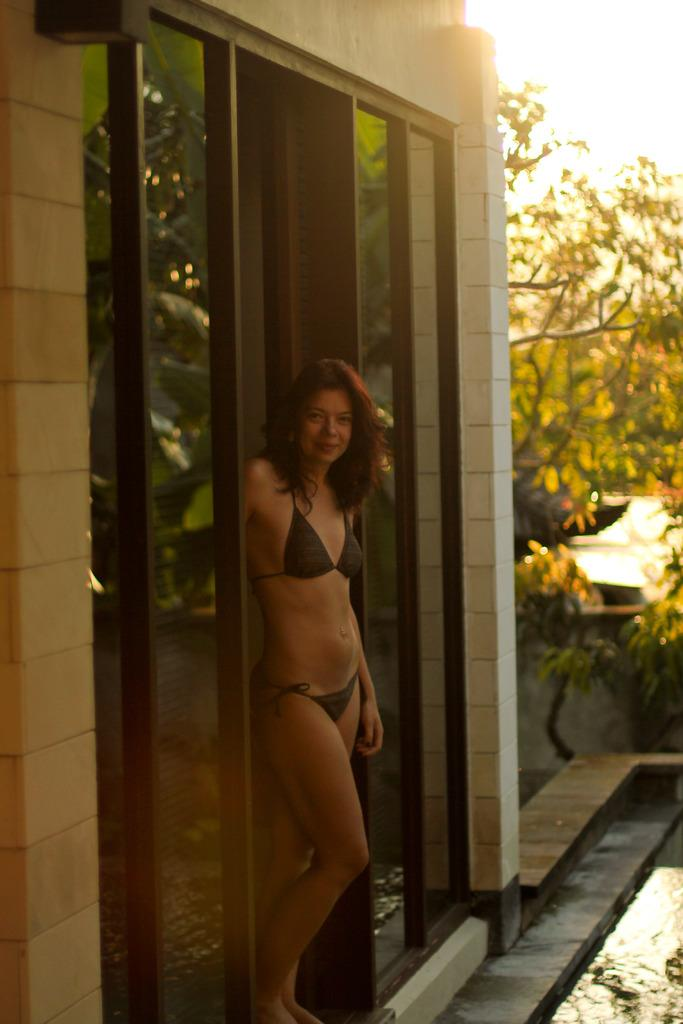What is the main subject of the image? There is a woman standing in the image. What can be seen in the background of the image? There is a building and trees in the background of the image. Can you describe an object in the image? There is a glass with water in the image. How much income does the woman earn in the image? There is no information about the woman's income in the image. Can you describe the bubbles in the image? There are no bubbles present in the image. 